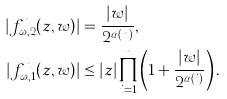<formula> <loc_0><loc_0><loc_500><loc_500>| f _ { \omega , 2 } ^ { n } ( z , w ) | & = \frac { | w | } { 2 ^ { \alpha ( n ) } } , \\ | f _ { \omega , 1 } ^ { n } ( z , w ) | & \leq | z | \prod _ { i = 1 } ^ { n } \left ( 1 + \frac { | w | } { 2 ^ { \alpha ( i ) } } \right ) .</formula> 